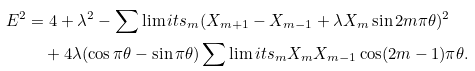Convert formula to latex. <formula><loc_0><loc_0><loc_500><loc_500>E ^ { 2 } & = 4 + \lambda ^ { 2 } - \sum \lim i t s _ { m } ( X _ { m + 1 } - X _ { m - 1 } + \lambda X _ { m } \sin 2 m \pi \theta ) ^ { 2 } \\ & \quad + 4 \lambda ( \cos \pi \theta - \sin \pi \theta ) \sum \lim i t s _ { m } X _ { m } X _ { m - 1 } \cos ( 2 m - 1 ) \pi \theta .</formula> 